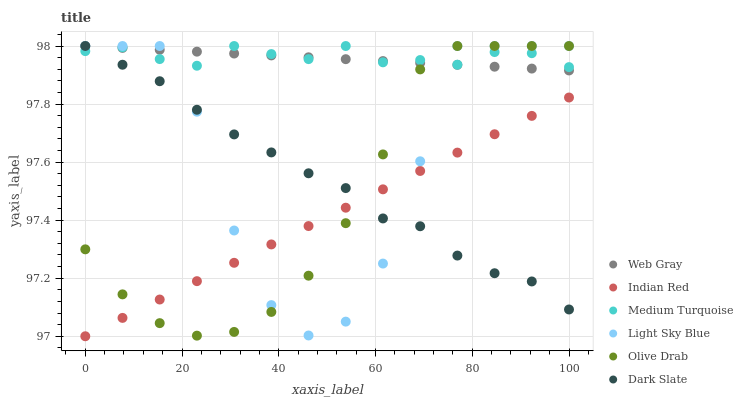Does Indian Red have the minimum area under the curve?
Answer yes or no. Yes. Does Medium Turquoise have the maximum area under the curve?
Answer yes or no. Yes. Does Dark Slate have the minimum area under the curve?
Answer yes or no. No. Does Dark Slate have the maximum area under the curve?
Answer yes or no. No. Is Web Gray the smoothest?
Answer yes or no. Yes. Is Light Sky Blue the roughest?
Answer yes or no. Yes. Is Indian Red the smoothest?
Answer yes or no. No. Is Indian Red the roughest?
Answer yes or no. No. Does Indian Red have the lowest value?
Answer yes or no. Yes. Does Dark Slate have the lowest value?
Answer yes or no. No. Does Olive Drab have the highest value?
Answer yes or no. Yes. Does Indian Red have the highest value?
Answer yes or no. No. Is Indian Red less than Web Gray?
Answer yes or no. Yes. Is Web Gray greater than Indian Red?
Answer yes or no. Yes. Does Light Sky Blue intersect Dark Slate?
Answer yes or no. Yes. Is Light Sky Blue less than Dark Slate?
Answer yes or no. No. Is Light Sky Blue greater than Dark Slate?
Answer yes or no. No. Does Indian Red intersect Web Gray?
Answer yes or no. No. 